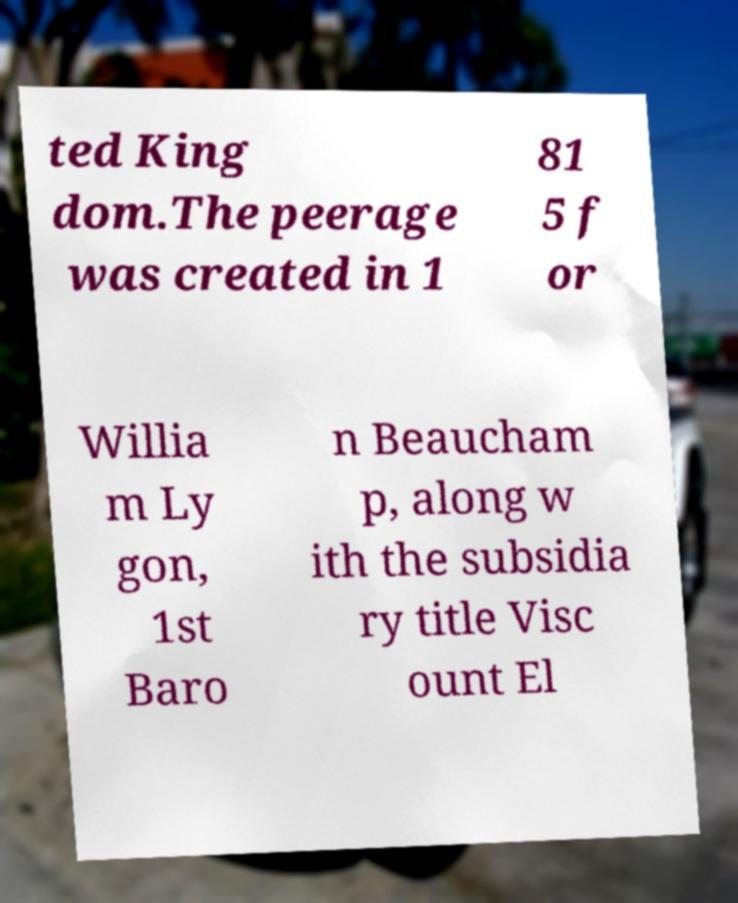Please identify and transcribe the text found in this image. ted King dom.The peerage was created in 1 81 5 f or Willia m Ly gon, 1st Baro n Beaucham p, along w ith the subsidia ry title Visc ount El 